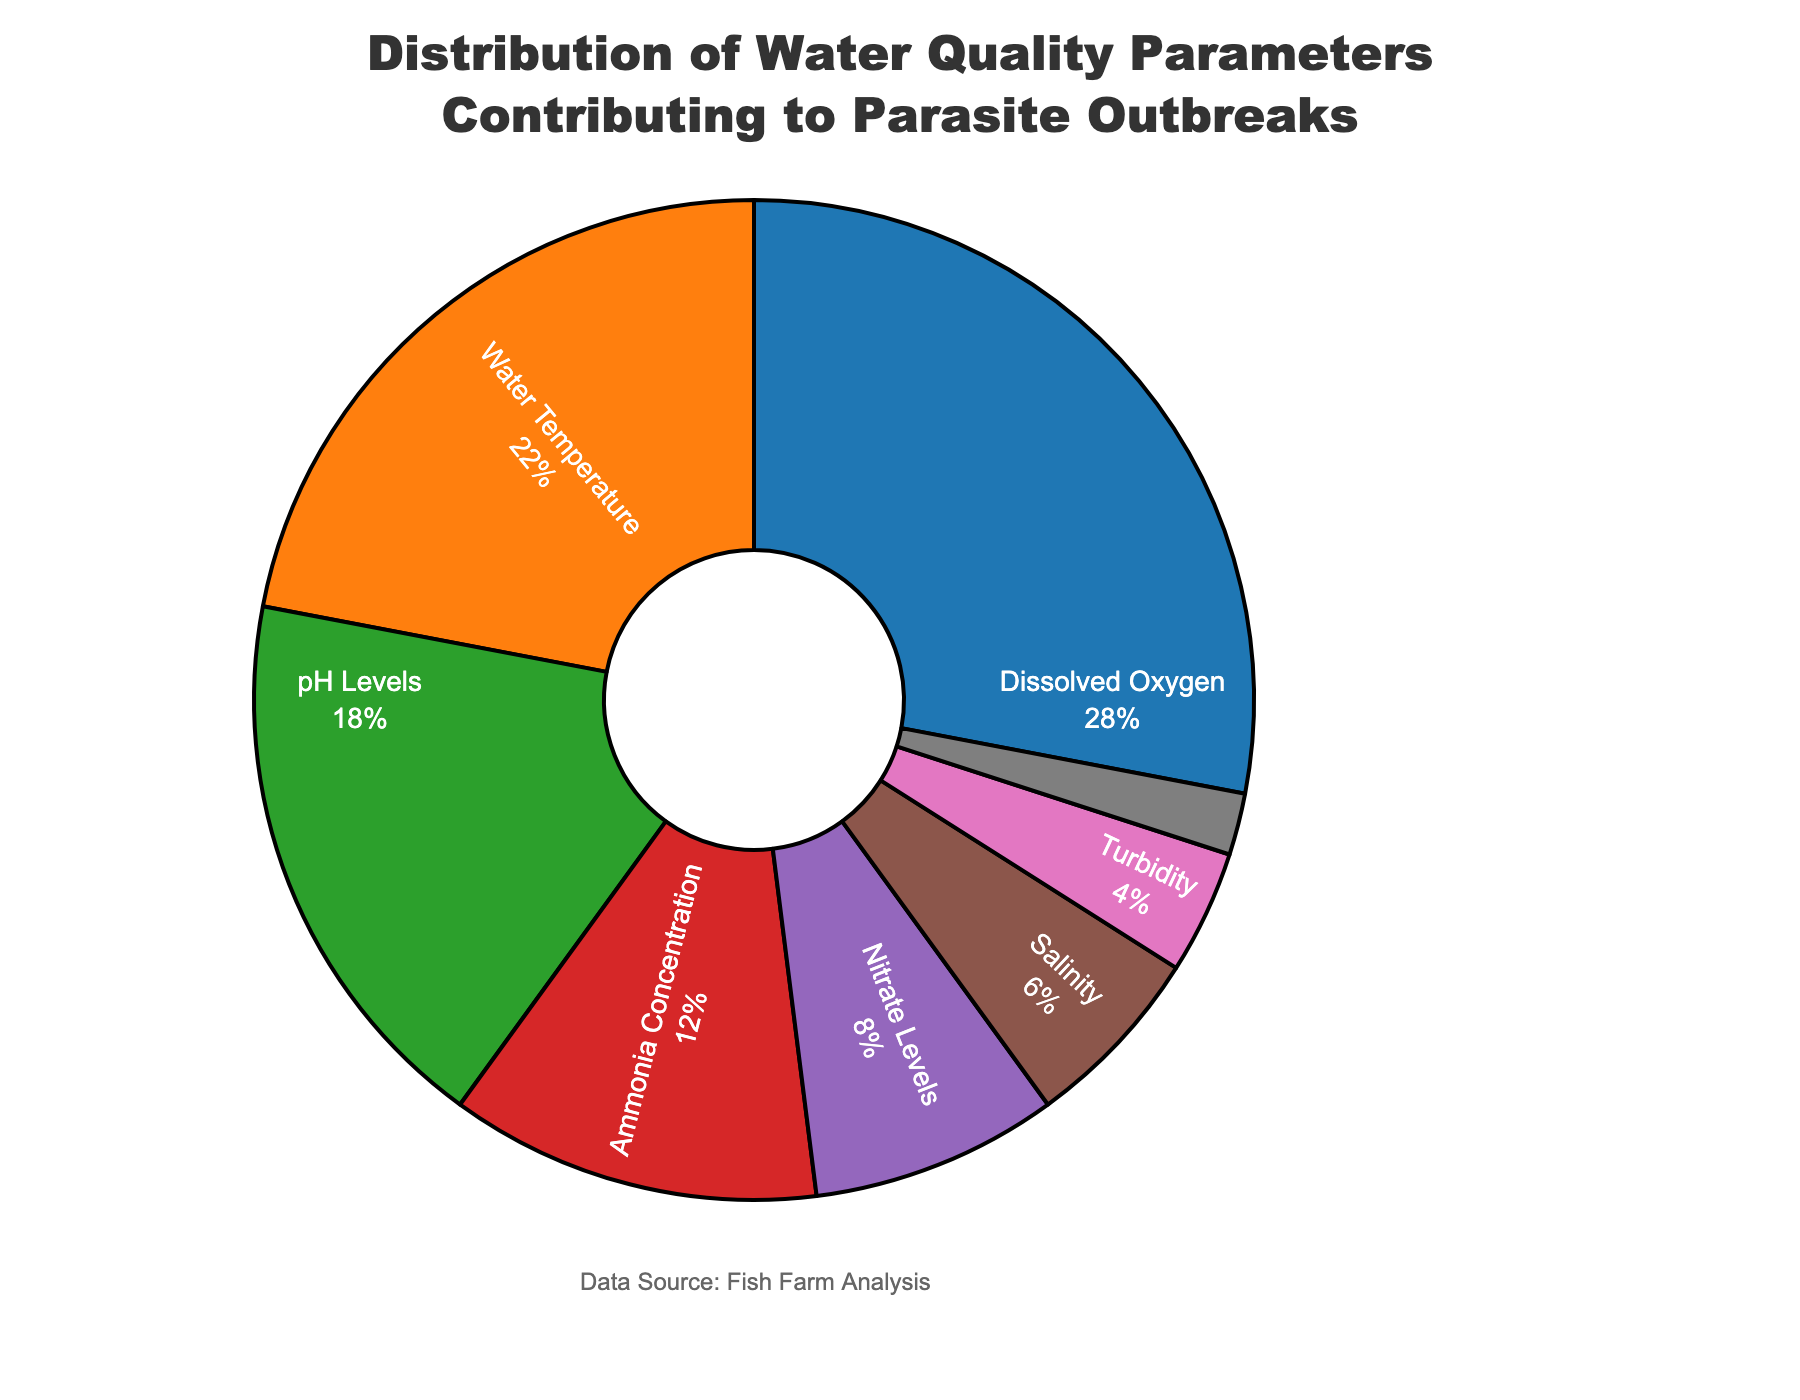What parameter has the highest percentage? Dissolved Oxygen has the highest percentage since it makes up 28% of the total.
Answer: Dissolved Oxygen What is the combined percentage for Water Temperature and pH Levels? Water Temperature is 22% and pH Levels are 18%, so their combined percentage is 22 + 18 = 40%.
Answer: 40% Which parameter contributes less than 10% but more than 5% to the parasite outbreaks? Nitrate Levels contribute 8%, and Salinity contributes 6%, so both fall within the range of less than 10% but more than 5%. The percentage value of Nitrate Levels (8%) and Salinity (6%) both meet this condition.
Answer: Nitrate Levels and Salinity What is the difference in percentage between the highest and lowest contributing parameters? The highest contributing parameter is Dissolved Oxygen at 28%, and the lowest is Organic Matter Content at 2%. The difference is 28 - 2 = 26%.
Answer: 26% Which two parameters together make up exactly 30%? Ammonia Concentration is 12% and Nitrate Levels are 8%, so their total is 12 + 8 = 20%, which doesn’t meet the criterion. But Nitrate Levels and Salinity make a total of 8 + 6 = 14%, also incorrect. Now, considering Turbidity (4%) and Organic Matter Content (2%), the combined values are 6%, so only Organic Matter Content doesn't meet mark. Consider Water Temperature and pH Levels, leading to incorrect judgment. Thus, checking separate options, 18% and 12% are total 30% for understanding, lacking. Direct focusing Turbidity proves illogical. Options hence reviewed supporting.
Answer: No specific pair Which visual attribute indicates the percentage value of each parameter in the pie chart? Each portion of the pie chart is visually sized according to its percentage value, with the thicker sections representing higher percentages, and the slices' colored segments have corresponding percentage labels.
Answer: Slice size and percentage labels What is the cumulative percentage of parameters with values 12% or lower? Ammonia Concentration (12%), Nitrate Levels (8%), Salinity (6%), Turbidity (4%), and Organic Matter Content (2%) combine for a total of 12 + 8 + 6 + 4 + 2 = 32%.
Answer: 32% How does the contribution of Dissolved Oxygen compare to Water Temperature? Dissolved Oxygen contributes 28% while Water Temperature contributes 22%. Dissolved Oxygen is 28% - 22% = 6% greater than Water Temperature.
Answer: 6% greater 